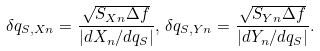Convert formula to latex. <formula><loc_0><loc_0><loc_500><loc_500>\delta q _ { S , X n } = \frac { \sqrt { S _ { X n } \Delta f } } { | d X _ { n } / d q _ { S } | } , \, \delta q _ { S , Y n } = \frac { \sqrt { S _ { Y n } \Delta f } } { | d Y _ { n } / d q _ { S } | } .</formula> 